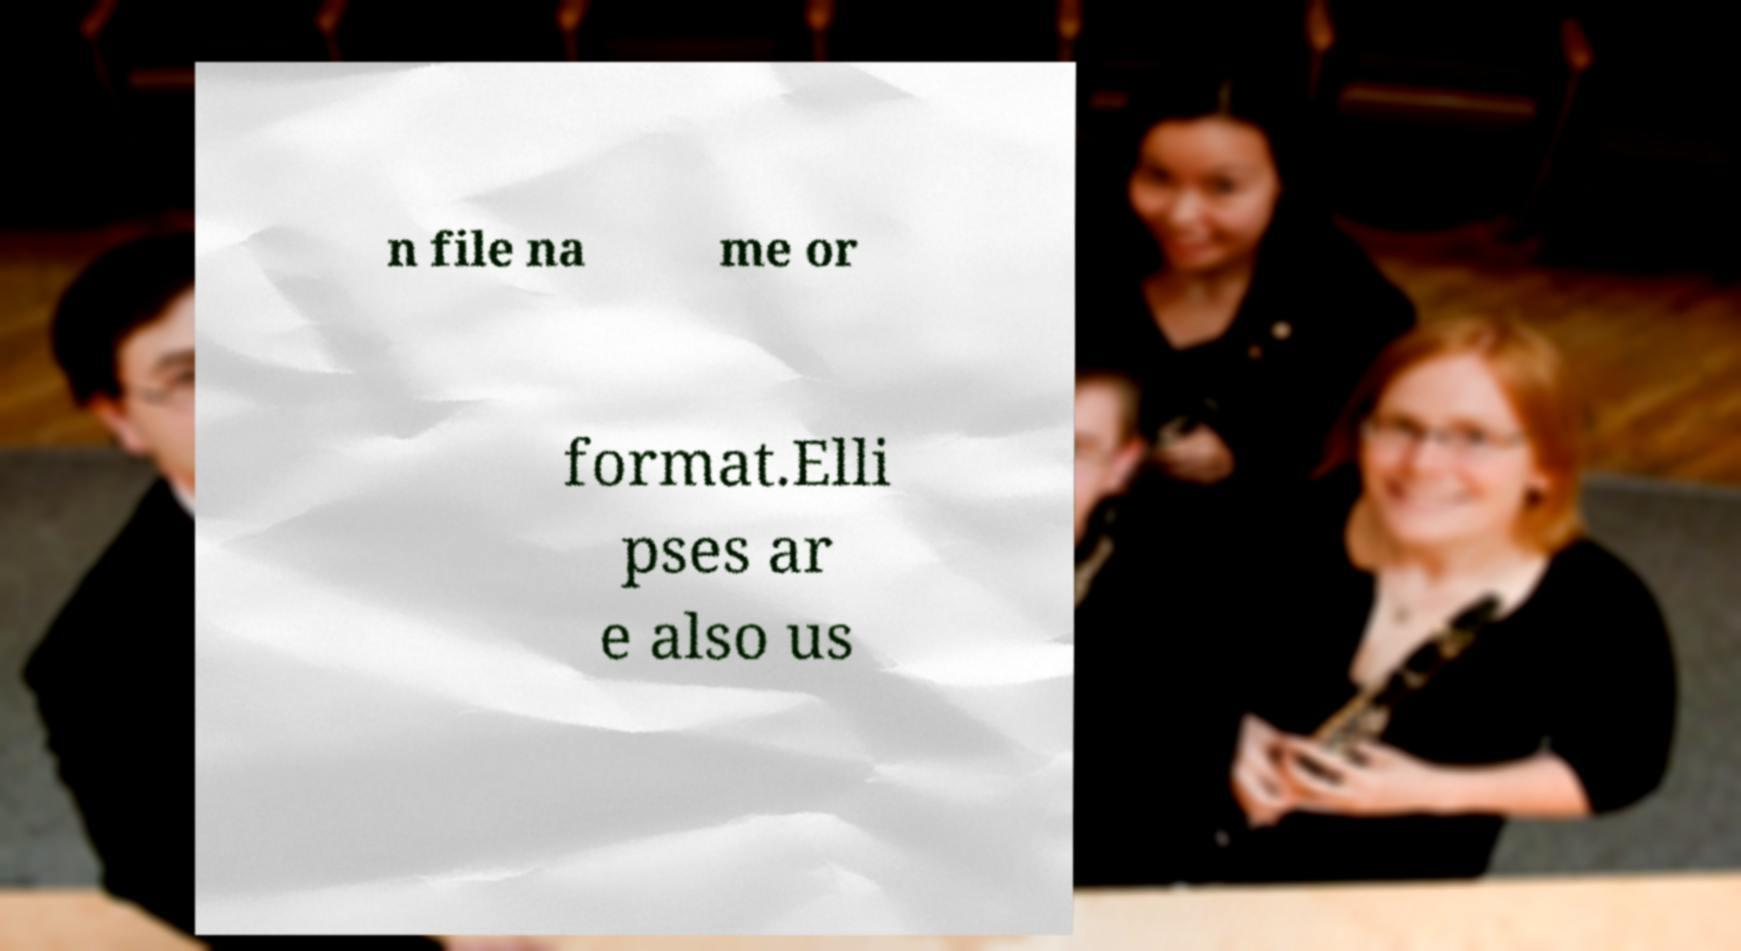What messages or text are displayed in this image? I need them in a readable, typed format. n file na me or format.Elli pses ar e also us 